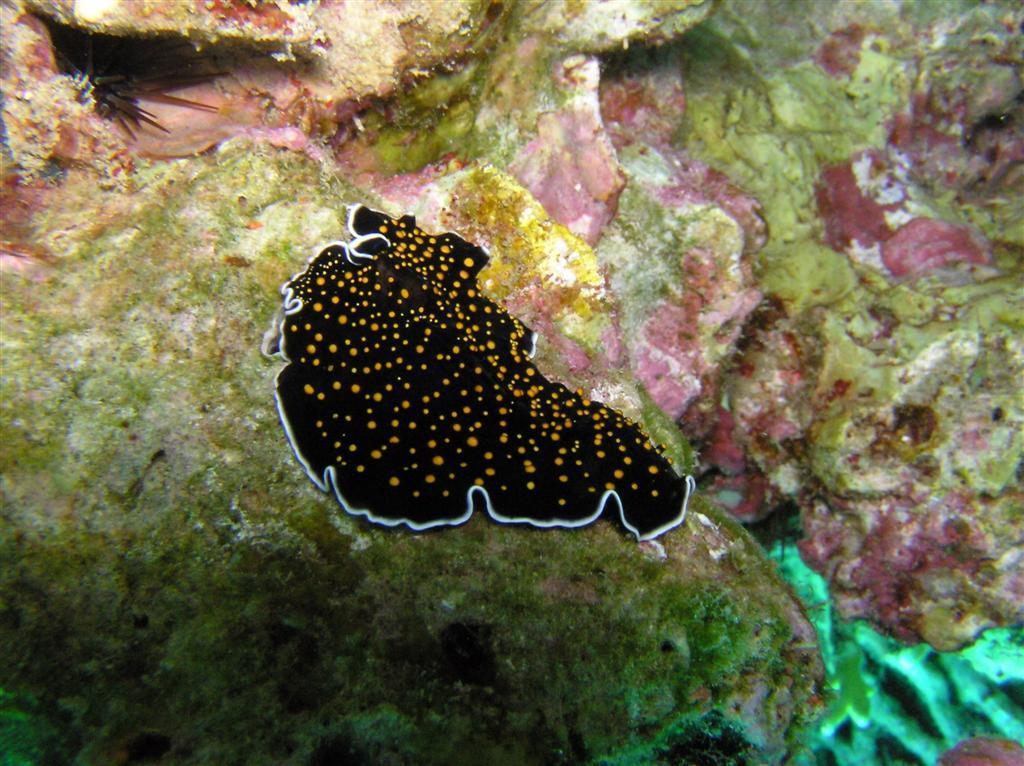What is the main subject of the image? The main subject of the image is a colorful stone. What can be seen on the stone in the image? There is an insect visible on the stone in the image. What type of fruit is growing on the stone in the image? There is no fruit growing on the stone in the image. What type of mineral is the stone made of in the image? The facts provided do not specify the type of mineral the stone is made of. 